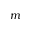<formula> <loc_0><loc_0><loc_500><loc_500>m</formula> 